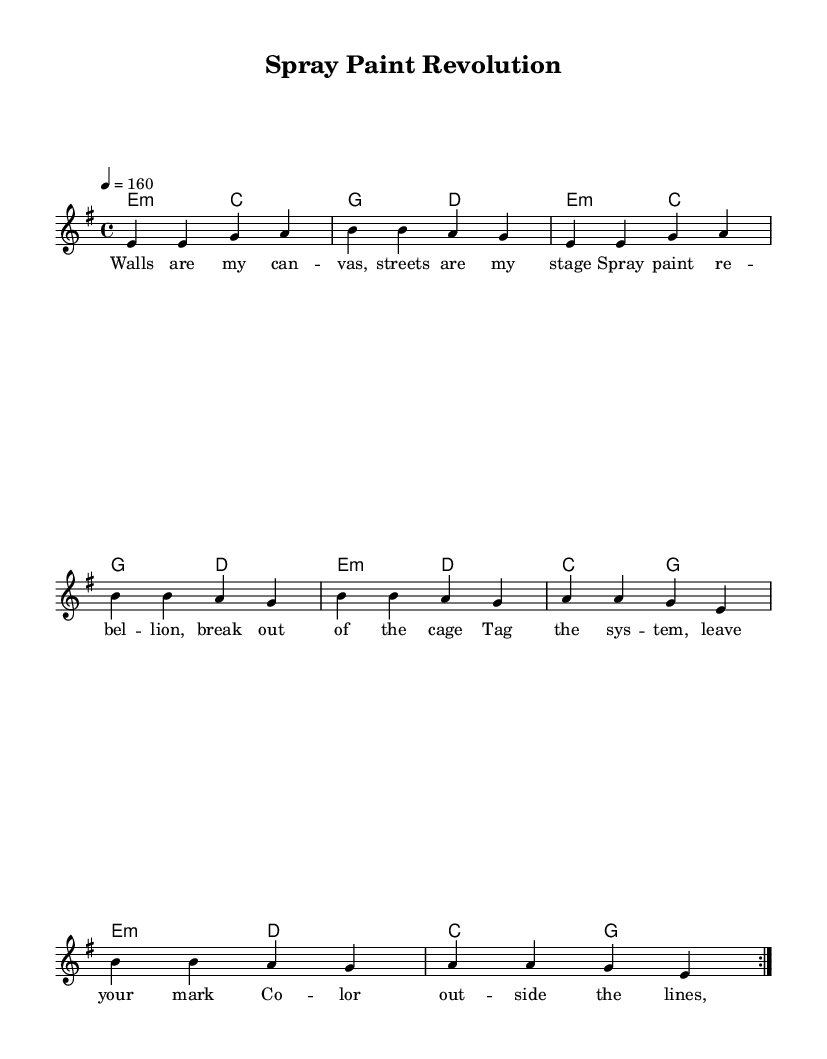What is the key signature of this music? The key signature is E minor, which has one sharp (F sharp). It can be found indicated at the beginning of the staff section.
Answer: E minor What is the time signature of this music? The time signature is 4/4, as indicated at the beginning of the score, which means there are four beats in each measure, and the quarter note gets one beat.
Answer: 4/4 What is the tempo marking for the piece? The tempo marking is 160 beats per minute, indicated by the tempo notation "4 = 160" at the beginning of the score.
Answer: 160 How many verses are present in the lyrics? The lyrics consist of one verse followed by a chorus, with the verse being clear from the layout of the text under the music notes. Therefore, only one verse section is there.
Answer: 1 Which chords are used in the harmony section? The chords present in the harmony section include E minor, C major, G major, and D major. Each chord is represented in the chord mode showing the harmonic progression throughout the piece.
Answer: E minor, C major, G major, D major What is the lyrical theme of the song? The lyrical theme centers around rebellion and self-expression, as highlighted in phrases like "Spray paint rebellion" and "Tag the system." It conveys a message of defiance and creativity common in punk rock anthems.
Answer: Rebellion and self-expression 